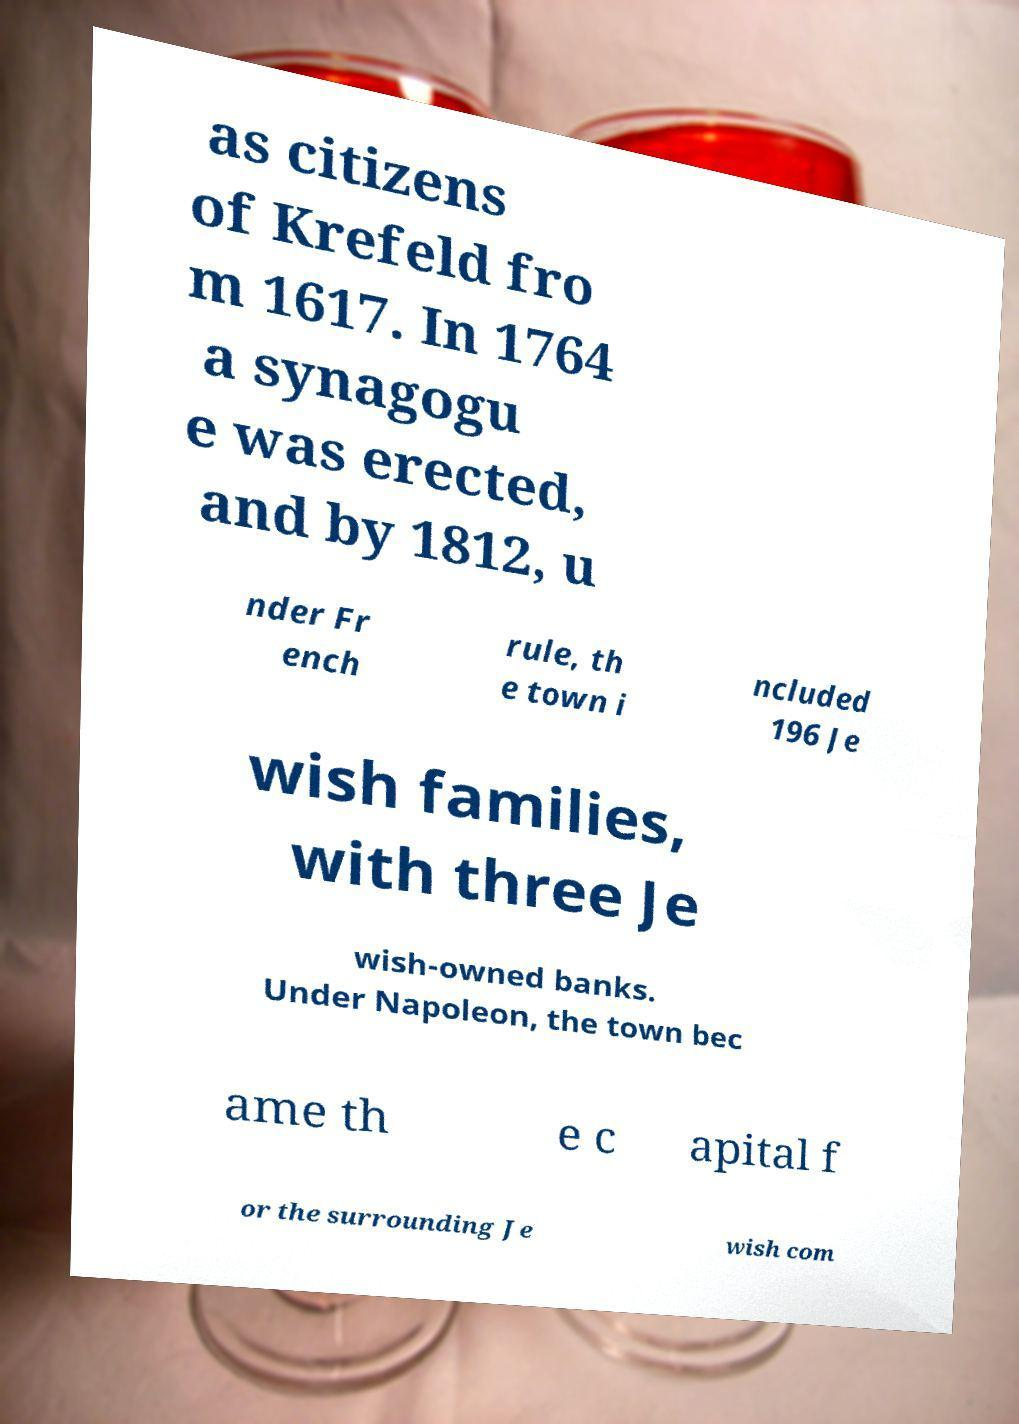I need the written content from this picture converted into text. Can you do that? as citizens of Krefeld fro m 1617. In 1764 a synagogu e was erected, and by 1812, u nder Fr ench rule, th e town i ncluded 196 Je wish families, with three Je wish-owned banks. Under Napoleon, the town bec ame th e c apital f or the surrounding Je wish com 